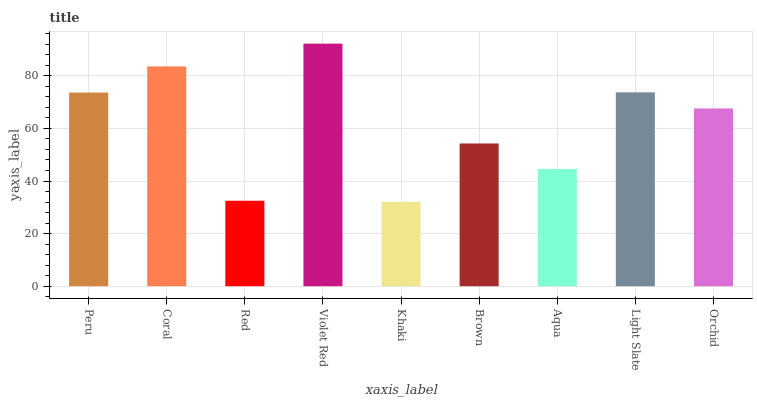Is Coral the minimum?
Answer yes or no. No. Is Coral the maximum?
Answer yes or no. No. Is Coral greater than Peru?
Answer yes or no. Yes. Is Peru less than Coral?
Answer yes or no. Yes. Is Peru greater than Coral?
Answer yes or no. No. Is Coral less than Peru?
Answer yes or no. No. Is Orchid the high median?
Answer yes or no. Yes. Is Orchid the low median?
Answer yes or no. Yes. Is Khaki the high median?
Answer yes or no. No. Is Coral the low median?
Answer yes or no. No. 